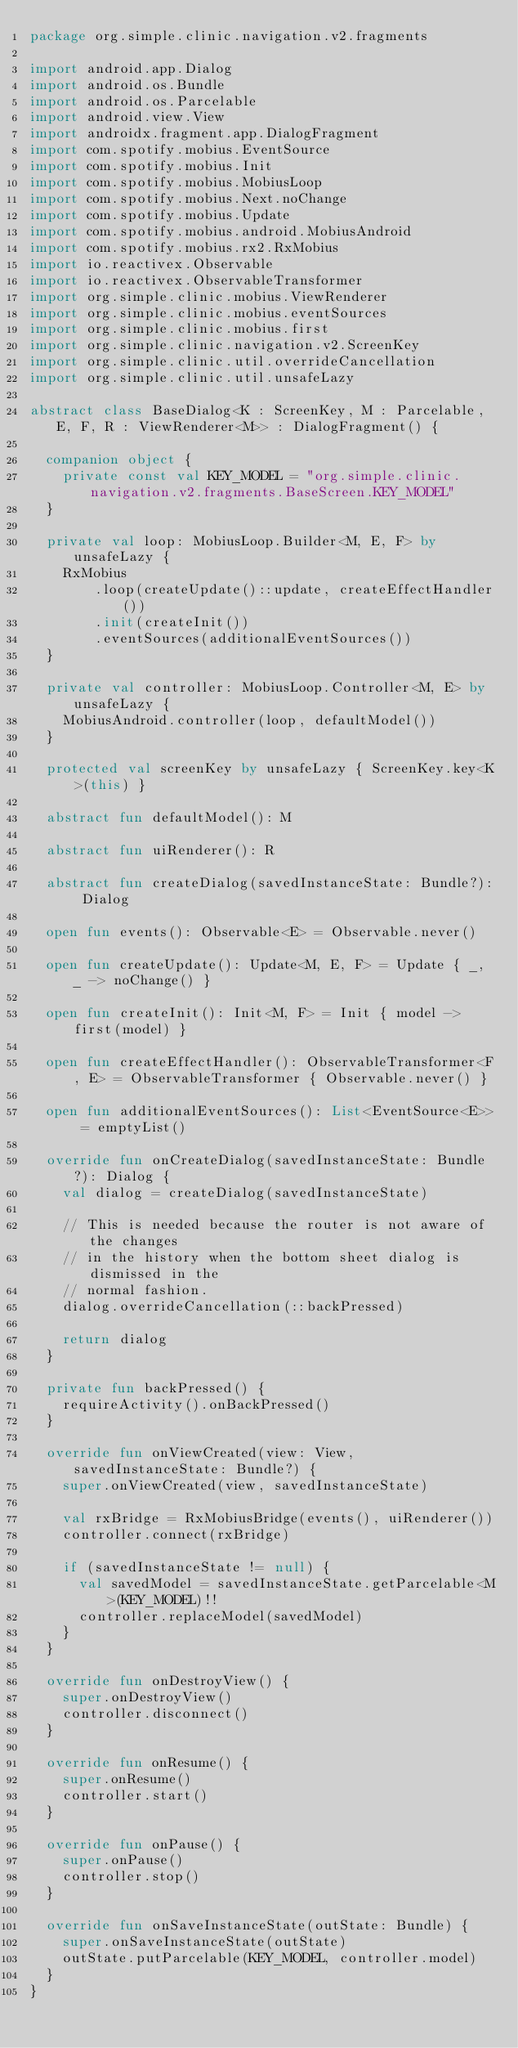Convert code to text. <code><loc_0><loc_0><loc_500><loc_500><_Kotlin_>package org.simple.clinic.navigation.v2.fragments

import android.app.Dialog
import android.os.Bundle
import android.os.Parcelable
import android.view.View
import androidx.fragment.app.DialogFragment
import com.spotify.mobius.EventSource
import com.spotify.mobius.Init
import com.spotify.mobius.MobiusLoop
import com.spotify.mobius.Next.noChange
import com.spotify.mobius.Update
import com.spotify.mobius.android.MobiusAndroid
import com.spotify.mobius.rx2.RxMobius
import io.reactivex.Observable
import io.reactivex.ObservableTransformer
import org.simple.clinic.mobius.ViewRenderer
import org.simple.clinic.mobius.eventSources
import org.simple.clinic.mobius.first
import org.simple.clinic.navigation.v2.ScreenKey
import org.simple.clinic.util.overrideCancellation
import org.simple.clinic.util.unsafeLazy

abstract class BaseDialog<K : ScreenKey, M : Parcelable, E, F, R : ViewRenderer<M>> : DialogFragment() {

  companion object {
    private const val KEY_MODEL = "org.simple.clinic.navigation.v2.fragments.BaseScreen.KEY_MODEL"
  }

  private val loop: MobiusLoop.Builder<M, E, F> by unsafeLazy {
    RxMobius
        .loop(createUpdate()::update, createEffectHandler())
        .init(createInit())
        .eventSources(additionalEventSources())
  }

  private val controller: MobiusLoop.Controller<M, E> by unsafeLazy {
    MobiusAndroid.controller(loop, defaultModel())
  }

  protected val screenKey by unsafeLazy { ScreenKey.key<K>(this) }

  abstract fun defaultModel(): M

  abstract fun uiRenderer(): R

  abstract fun createDialog(savedInstanceState: Bundle?): Dialog

  open fun events(): Observable<E> = Observable.never()

  open fun createUpdate(): Update<M, E, F> = Update { _, _ -> noChange() }

  open fun createInit(): Init<M, F> = Init { model -> first(model) }

  open fun createEffectHandler(): ObservableTransformer<F, E> = ObservableTransformer { Observable.never() }

  open fun additionalEventSources(): List<EventSource<E>> = emptyList()

  override fun onCreateDialog(savedInstanceState: Bundle?): Dialog {
    val dialog = createDialog(savedInstanceState)

    // This is needed because the router is not aware of the changes
    // in the history when the bottom sheet dialog is dismissed in the
    // normal fashion.
    dialog.overrideCancellation(::backPressed)

    return dialog
  }

  private fun backPressed() {
    requireActivity().onBackPressed()
  }

  override fun onViewCreated(view: View, savedInstanceState: Bundle?) {
    super.onViewCreated(view, savedInstanceState)

    val rxBridge = RxMobiusBridge(events(), uiRenderer())
    controller.connect(rxBridge)

    if (savedInstanceState != null) {
      val savedModel = savedInstanceState.getParcelable<M>(KEY_MODEL)!!
      controller.replaceModel(savedModel)
    }
  }

  override fun onDestroyView() {
    super.onDestroyView()
    controller.disconnect()
  }

  override fun onResume() {
    super.onResume()
    controller.start()
  }

  override fun onPause() {
    super.onPause()
    controller.stop()
  }

  override fun onSaveInstanceState(outState: Bundle) {
    super.onSaveInstanceState(outState)
    outState.putParcelable(KEY_MODEL, controller.model)
  }
}
</code> 